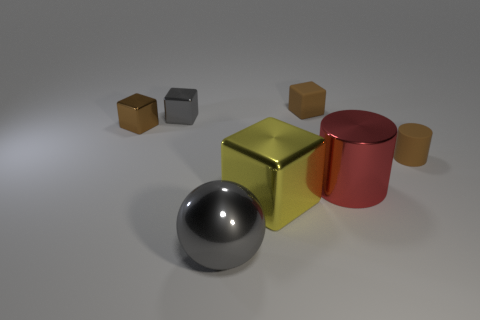Add 3 small blocks. How many objects exist? 10 Subtract all blocks. How many objects are left? 3 Subtract all small gray rubber balls. Subtract all spheres. How many objects are left? 6 Add 2 large yellow metal things. How many large yellow metal things are left? 3 Add 7 large metallic cylinders. How many large metallic cylinders exist? 8 Subtract 1 gray cubes. How many objects are left? 6 